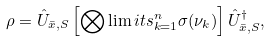<formula> <loc_0><loc_0><loc_500><loc_500>\rho = \hat { U } _ { \bar { x } , S } \left [ \bigotimes \lim i t s _ { k = 1 } ^ { n } \sigma ( \nu _ { k } ) \right ] \hat { U } _ { \bar { x } , S } ^ { \dagger } ,</formula> 